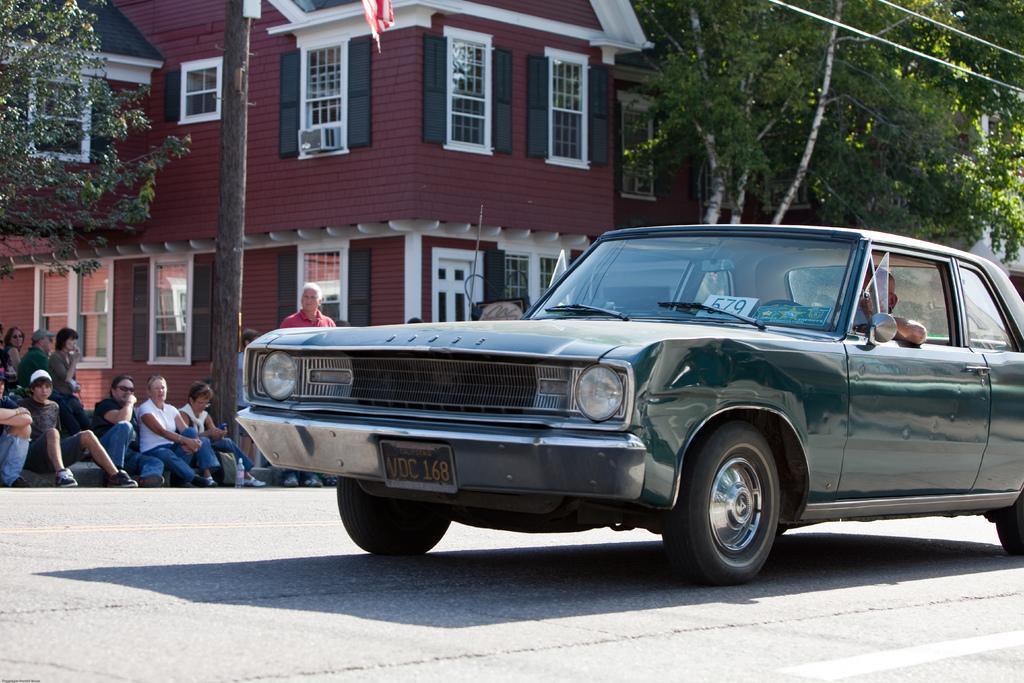Please provide a concise description of this image. In this image in the foreground there is a car, and in the car there is one man sitting. And in the background there are some people sitting and there are some houses, trees, wires and at the bottom there is a road. 